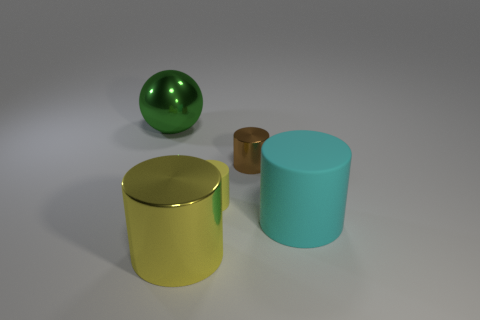How many other objects are there of the same material as the large cyan thing?
Keep it short and to the point. 1. What material is the green object?
Make the answer very short. Metal. What is the size of the yellow object that is behind the large cyan cylinder?
Provide a succinct answer. Small. How many big yellow shiny objects are behind the small brown shiny thing on the right side of the small rubber cylinder?
Offer a very short reply. 0. There is a tiny brown thing on the left side of the large matte cylinder; does it have the same shape as the tiny thing that is left of the brown shiny object?
Offer a terse response. Yes. What number of big things are both right of the big green ball and behind the yellow metal cylinder?
Keep it short and to the point. 1. Are there any big shiny cylinders of the same color as the small rubber thing?
Give a very brief answer. Yes. There is a shiny thing that is the same size as the yellow rubber thing; what is its shape?
Your answer should be very brief. Cylinder. There is a small metal cylinder; are there any yellow rubber things on the left side of it?
Give a very brief answer. Yes. Are the tiny cylinder behind the tiny matte cylinder and the tiny cylinder in front of the small brown metal thing made of the same material?
Provide a succinct answer. No. 